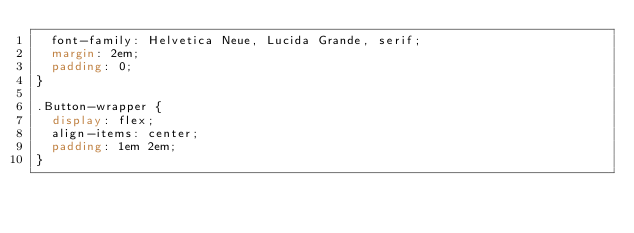Convert code to text. <code><loc_0><loc_0><loc_500><loc_500><_CSS_>  font-family: Helvetica Neue, Lucida Grande, serif;
  margin: 2em;
  padding: 0;
}

.Button-wrapper {
  display: flex;
  align-items: center;
  padding: 1em 2em;
}</code> 